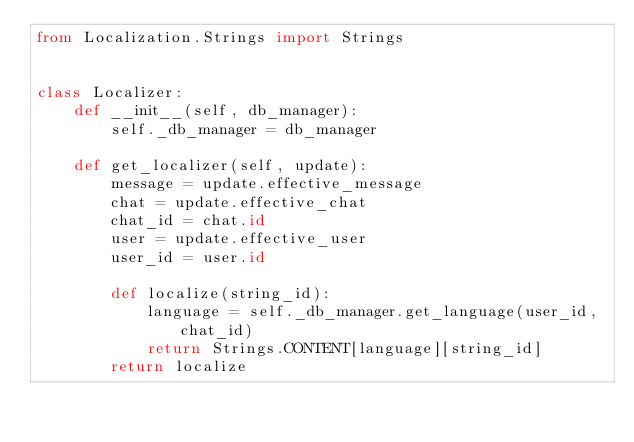Convert code to text. <code><loc_0><loc_0><loc_500><loc_500><_Python_>from Localization.Strings import Strings


class Localizer:
    def __init__(self, db_manager):
        self._db_manager = db_manager

    def get_localizer(self, update):
        message = update.effective_message
        chat = update.effective_chat
        chat_id = chat.id
        user = update.effective_user
        user_id = user.id

        def localize(string_id):
            language = self._db_manager.get_language(user_id, chat_id)
            return Strings.CONTENT[language][string_id]
        return localize
</code> 